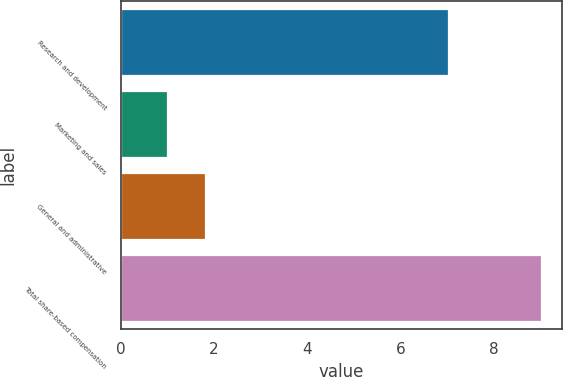Convert chart. <chart><loc_0><loc_0><loc_500><loc_500><bar_chart><fcel>Research and development<fcel>Marketing and sales<fcel>General and administrative<fcel>Total share-based compensation<nl><fcel>7<fcel>1<fcel>1.8<fcel>9<nl></chart> 